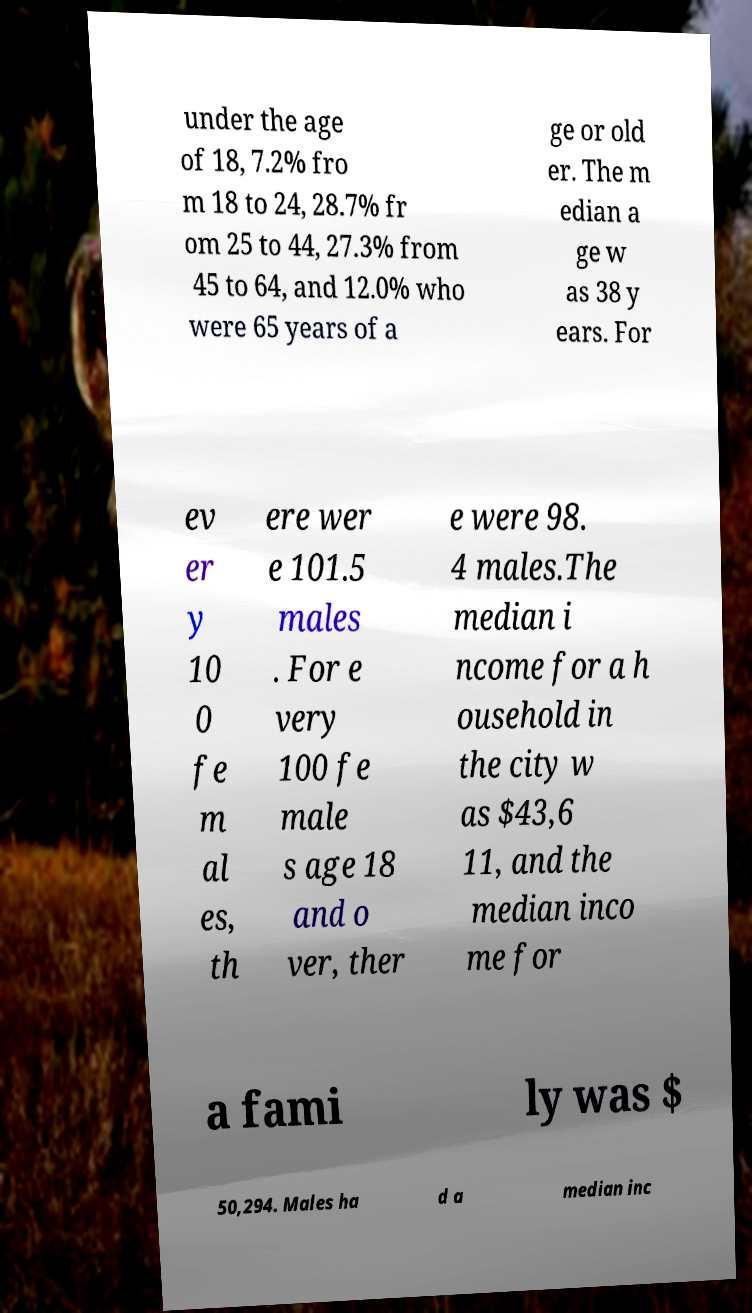Can you read and provide the text displayed in the image?This photo seems to have some interesting text. Can you extract and type it out for me? under the age of 18, 7.2% fro m 18 to 24, 28.7% fr om 25 to 44, 27.3% from 45 to 64, and 12.0% who were 65 years of a ge or old er. The m edian a ge w as 38 y ears. For ev er y 10 0 fe m al es, th ere wer e 101.5 males . For e very 100 fe male s age 18 and o ver, ther e were 98. 4 males.The median i ncome for a h ousehold in the city w as $43,6 11, and the median inco me for a fami ly was $ 50,294. Males ha d a median inc 